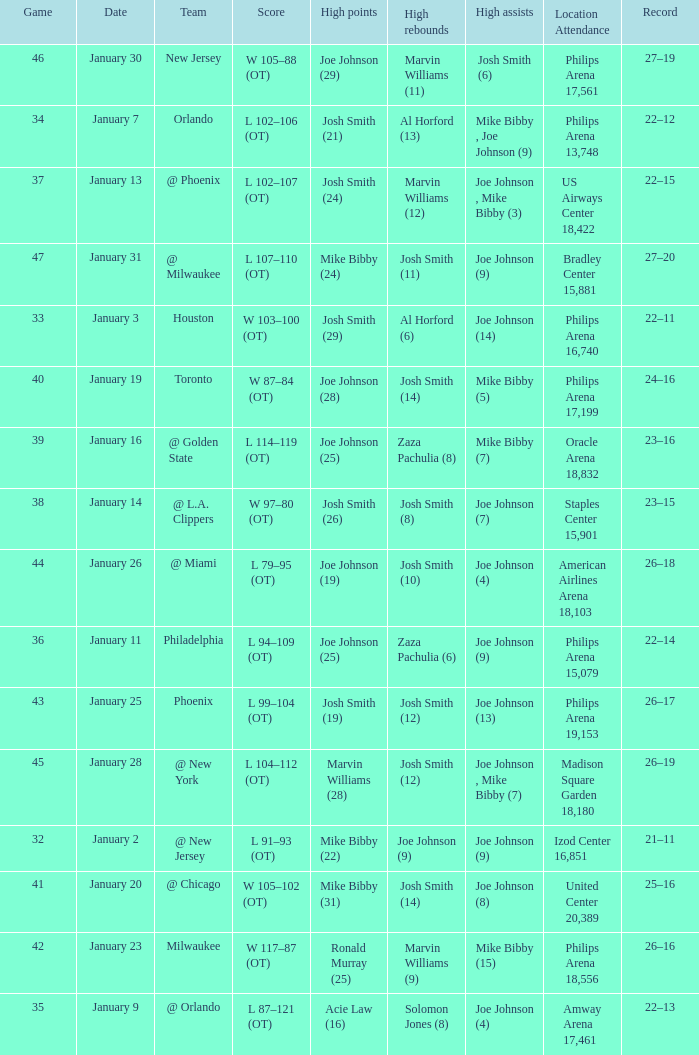Which date was game 35 on? January 9. 